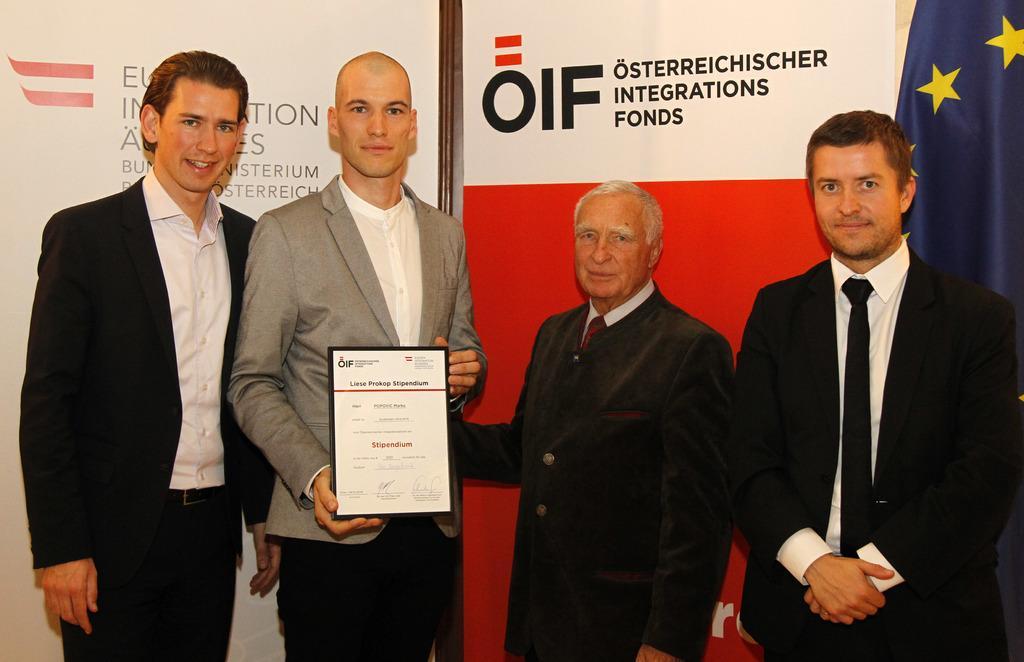Could you give a brief overview of what you see in this image? In this image I can see the group of people with white, black and an ash color dresses. I can see one person holding the board. In the background I can see the banners and the flag. 